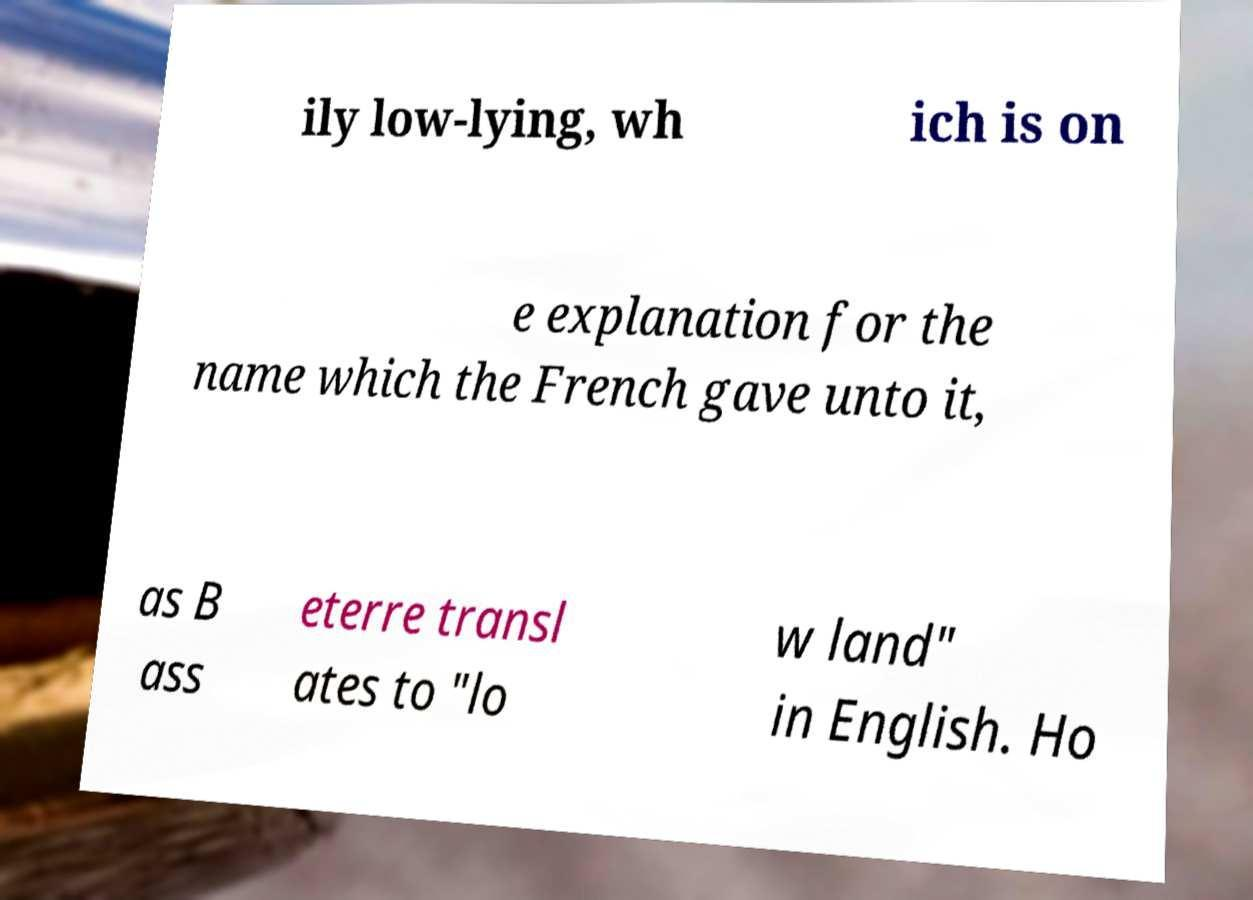There's text embedded in this image that I need extracted. Can you transcribe it verbatim? ily low-lying, wh ich is on e explanation for the name which the French gave unto it, as B ass eterre transl ates to "lo w land" in English. Ho 